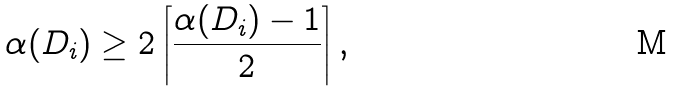Convert formula to latex. <formula><loc_0><loc_0><loc_500><loc_500>\alpha ( D _ { i } ) & \geq 2 \left \lceil \frac { \alpha ( D _ { i } ) - 1 } { 2 } \right \rceil ,</formula> 